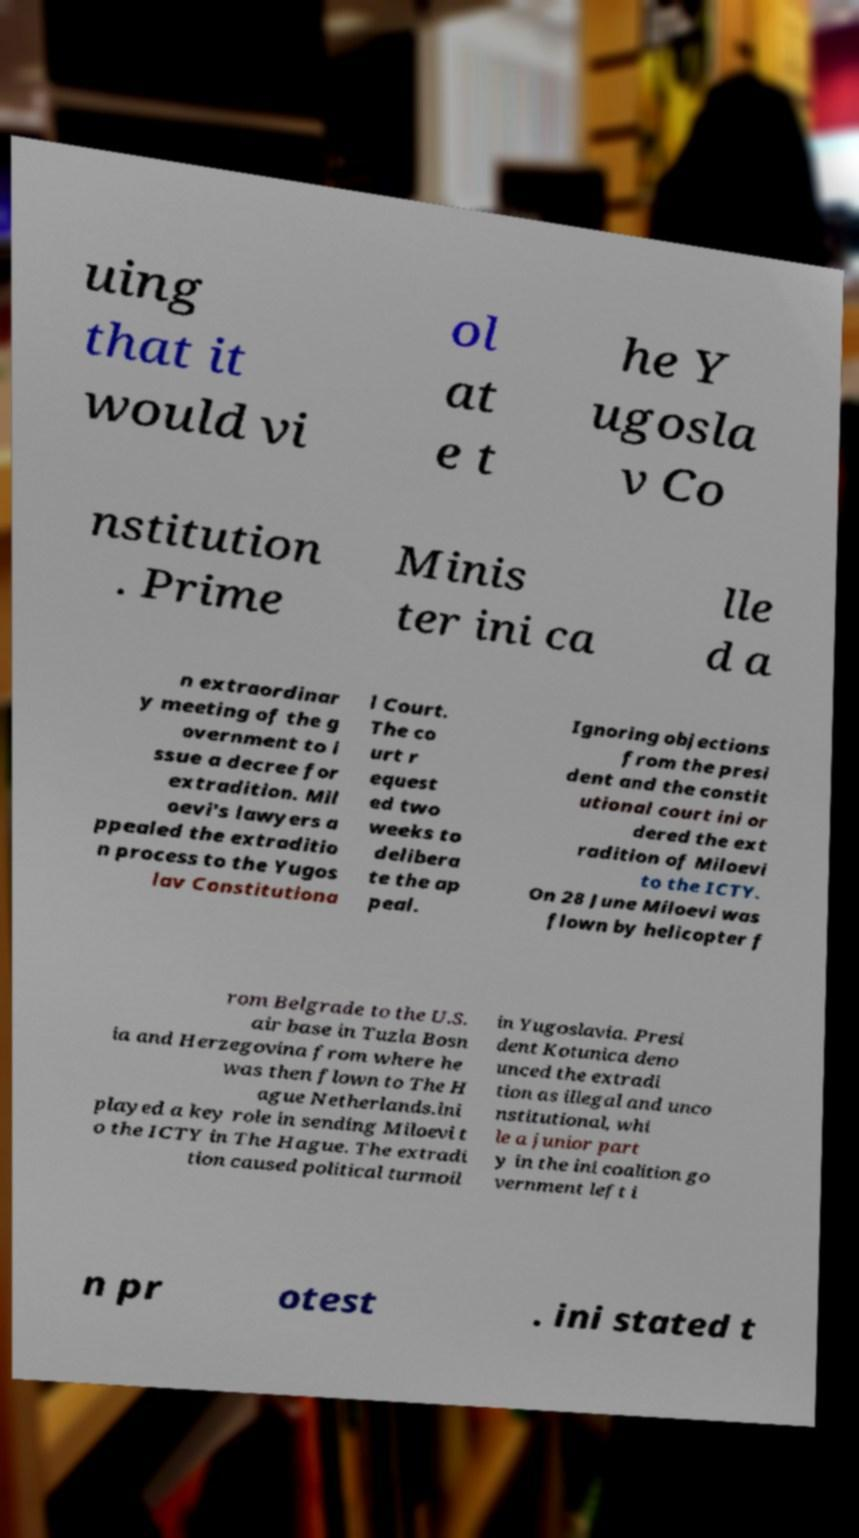Please identify and transcribe the text found in this image. uing that it would vi ol at e t he Y ugosla v Co nstitution . Prime Minis ter ini ca lle d a n extraordinar y meeting of the g overnment to i ssue a decree for extradition. Mil oevi's lawyers a ppealed the extraditio n process to the Yugos lav Constitutiona l Court. The co urt r equest ed two weeks to delibera te the ap peal. Ignoring objections from the presi dent and the constit utional court ini or dered the ext radition of Miloevi to the ICTY. On 28 June Miloevi was flown by helicopter f rom Belgrade to the U.S. air base in Tuzla Bosn ia and Herzegovina from where he was then flown to The H ague Netherlands.ini played a key role in sending Miloevi t o the ICTY in The Hague. The extradi tion caused political turmoil in Yugoslavia. Presi dent Kotunica deno unced the extradi tion as illegal and unco nstitutional, whi le a junior part y in the ini coalition go vernment left i n pr otest . ini stated t 